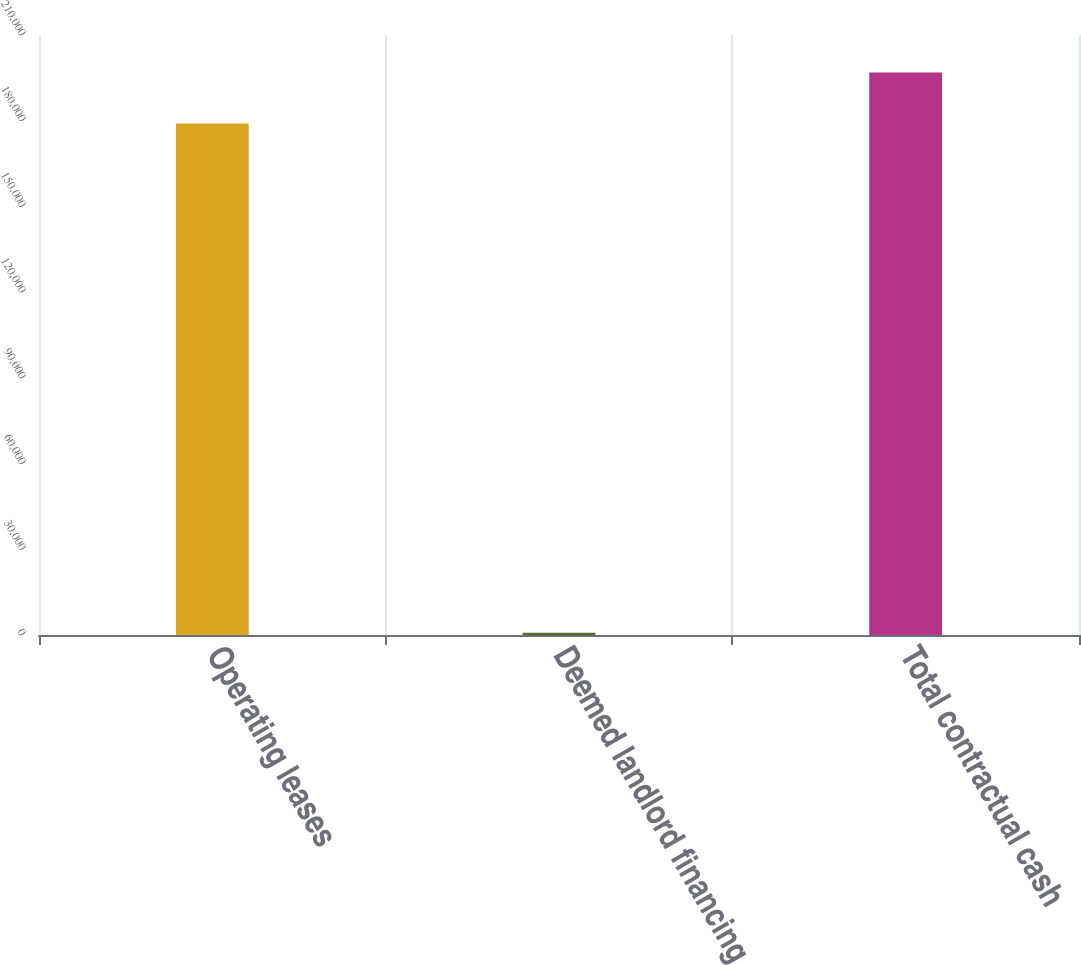Convert chart. <chart><loc_0><loc_0><loc_500><loc_500><bar_chart><fcel>Operating leases<fcel>Deemed landlord financing<fcel>Total contractual cash<nl><fcel>178998<fcel>788<fcel>196898<nl></chart> 